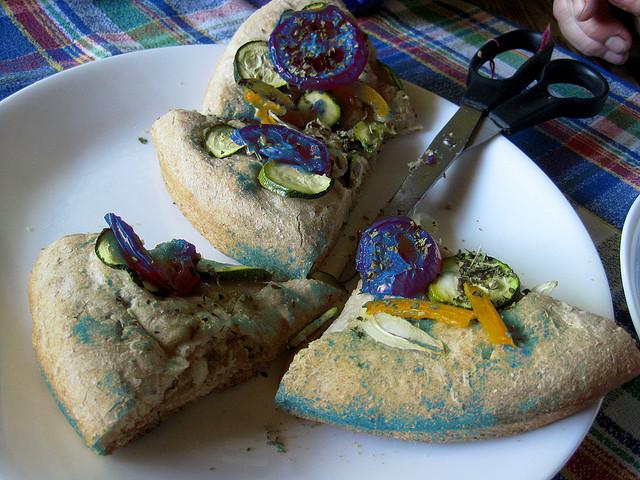What utensil is in this picture?
Quick response, please. Scissors. What color is the plate?
Concise answer only. White. Is this a healthy meal?
Short answer required. Yes. 